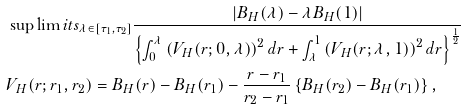<formula> <loc_0><loc_0><loc_500><loc_500>& \sup \lim i t s _ { \lambda \in \left [ \tau _ { 1 } , \tau _ { 2 } \right ] } \frac { \left | B _ { H } ( \lambda ) - \lambda B _ { H } ( 1 ) \right | } { \left \{ \int _ { 0 } ^ { \lambda } \left ( V _ { H } ( r ; 0 , \lambda ) \right ) ^ { 2 } d r + \int _ { \lambda } ^ { 1 } \left ( V _ { H } ( r ; \lambda , 1 ) \right ) ^ { 2 } d r \right \} ^ { \frac { 1 } { 2 } } } \\ & V _ { H } ( r ; r _ { 1 } , r _ { 2 } ) = B _ { H } ( r ) - B _ { H } ( r _ { 1 } ) - \frac { r - r _ { 1 } } { r _ { 2 } - r _ { 1 } } \left \{ B _ { H } ( r _ { 2 } ) - B _ { H } ( r _ { 1 } ) \right \} ,</formula> 